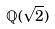Convert formula to latex. <formula><loc_0><loc_0><loc_500><loc_500>\mathbb { Q } ( \sqrt { 2 } )</formula> 